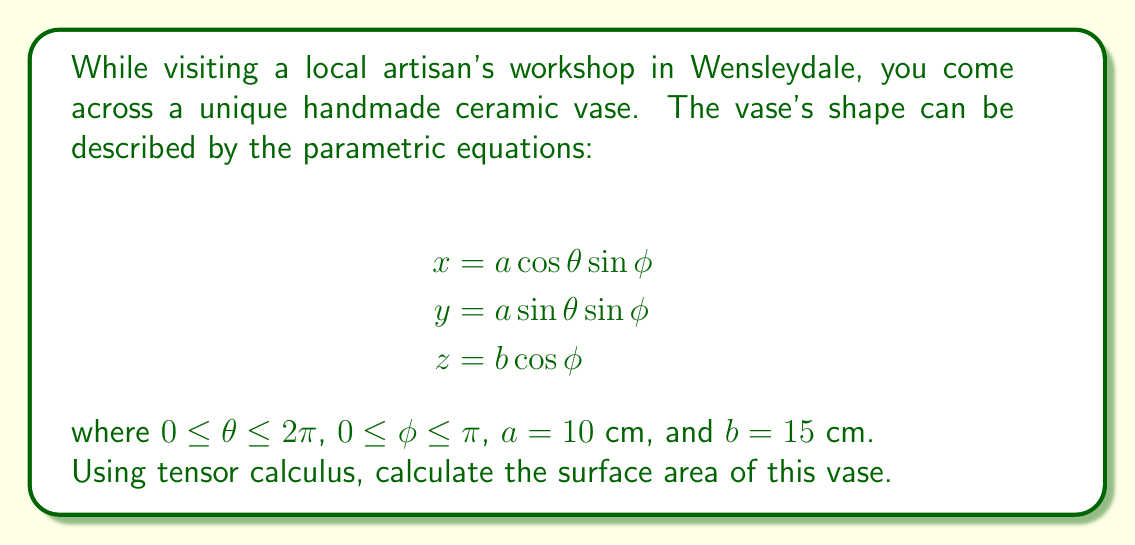Show me your answer to this math problem. To calculate the surface area using tensor calculus, we'll follow these steps:

1) First, we need to find the metric tensor $g_{ij}$. For a surface parameterized by $u^1 = \theta$ and $u^2 = \phi$, the metric tensor is given by:

   $g_{ij} = \frac{\partial \mathbf{r}}{\partial u^i} \cdot \frac{\partial \mathbf{r}}{\partial u^j}$

2) Calculate the partial derivatives:

   $\frac{\partial \mathbf{r}}{\partial \theta} = (-a\sin\theta\sin\phi, a\cos\theta\sin\phi, 0)$
   $\frac{\partial \mathbf{r}}{\partial \phi} = (a\cos\theta\cos\phi, a\sin\theta\cos\phi, -b\sin\phi)$

3) Now, let's compute the components of the metric tensor:

   $g_{11} = a^2\sin^2\phi$
   $g_{12} = g_{21} = 0$
   $g_{22} = a^2\cos^2\phi + b^2\sin^2\phi$

4) The determinant of the metric tensor is:

   $g = \det(g_{ij}) = a^2\sin^2\phi(a^2\cos^2\phi + b^2\sin^2\phi)$

5) The surface area is given by the integral:

   $A = \int\int \sqrt{g} d\theta d\phi$

6) Substituting and integrating:

   $A = \int_0^{2\pi} \int_0^{\pi} a\sin\phi\sqrt{a^2\cos^2\phi + b^2\sin^2\phi} d\phi d\theta$

   $= 2\pi a \int_0^{\pi} \sin\phi\sqrt{a^2\cos^2\phi + b^2\sin^2\phi} d\phi$

7) This integral doesn't have a simple closed form. We can simplify it by substituting $u = \cos\phi$:

   $A = 2\pi a \int_{-1}^1 \sqrt{a^2u^2 + b^2(1-u^2)} du$

   $= 2\pi a \int_{-1}^1 \sqrt{(b^2-a^2)u^2 + b^2} du$

8) This is an elliptic integral. The result is:

   $A = 2\pi ab \left[\frac{\sin\phi}{\epsilon}\sqrt{1-\epsilon^2\sin^2\phi} + \frac{1}{\epsilon}\arcsin(\epsilon\sin\phi)\right]_0^{\pi/2}$

   where $\epsilon = \sqrt{1-\frac{a^2}{b^2}}$

9) Evaluating at the limits and substituting $a=10$ and $b=15$:

   $A = 2\pi \cdot 10 \cdot 15 \left[\frac{1}{\epsilon} + \frac{1}{\epsilon}\arcsin(\epsilon)\right]$

   $= 300\pi \left[\frac{1}{\epsilon} + \frac{1}{\epsilon}\arcsin(\epsilon)\right]$ cm²

   where $\epsilon = \sqrt{1-\frac{100}{225}} = \frac{\sqrt{5}}{3}$
Answer: $300\pi \left[\frac{3}{\sqrt{5}} + \frac{3}{\sqrt{5}}\arcsin(\frac{\sqrt{5}}{3})\right]$ cm² 